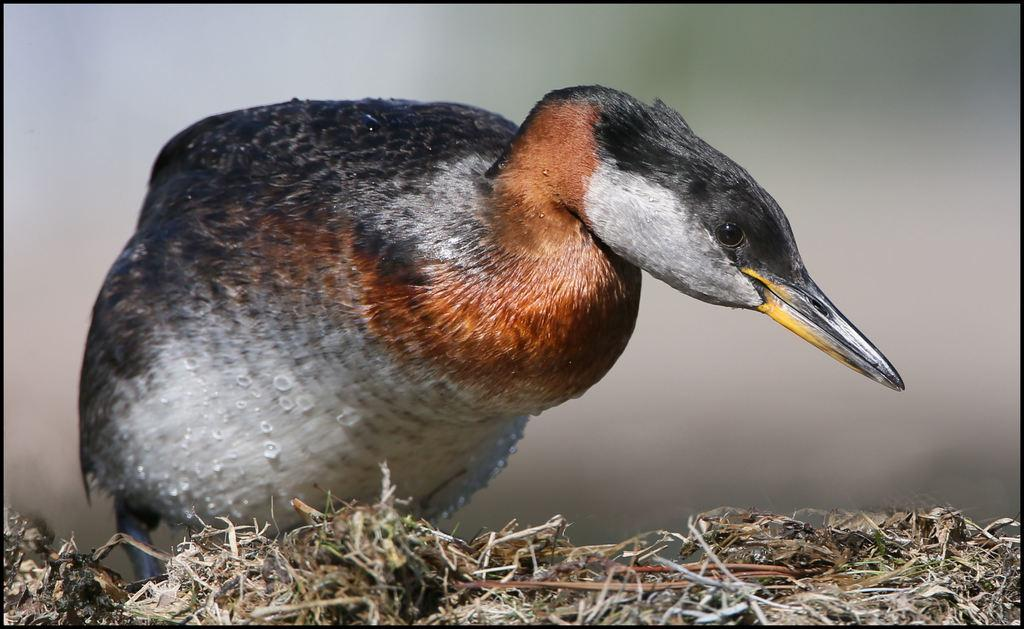What type of animal is present in the image? There is a bird in the image. What is the bird standing on? The bird is standing on dried grass. Can you describe the background of the image? The background of the image is blurred. What year is the bird signing an agreement in the image? There is no indication in the image that the bird is signing an agreement, nor is there any reference to a specific year. 